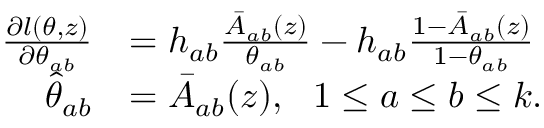Convert formula to latex. <formula><loc_0><loc_0><loc_500><loc_500>\begin{array} { r l } { \frac { \partial l ( \theta , z ) } { \partial \theta _ { a b } } } & { = h _ { a b } \frac { \bar { A } _ { a b } ( z ) } { \theta _ { a b } } - h _ { a b } \frac { 1 - \bar { A } _ { a b } ( z ) } { 1 - \theta _ { a b } } } \\ { \widehat { \theta } _ { a b } } & { = \bar { A } _ { a b } ( z ) , \ \ 1 \leq a \leq b \leq k . } \end{array}</formula> 